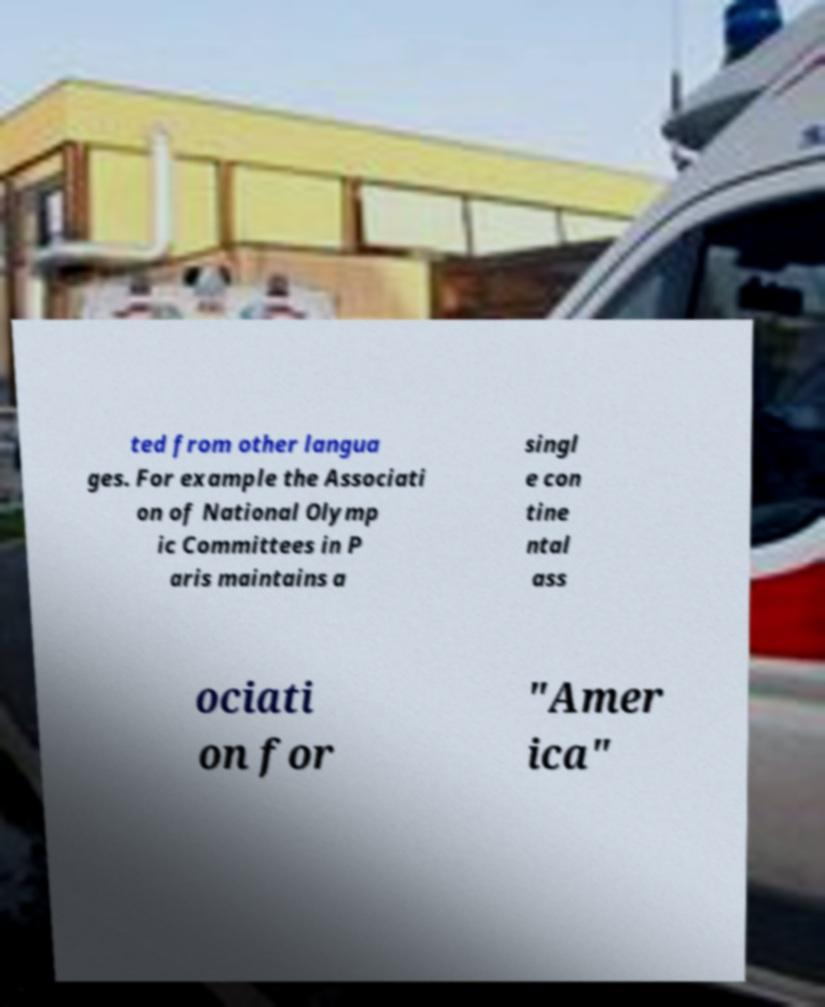There's text embedded in this image that I need extracted. Can you transcribe it verbatim? ted from other langua ges. For example the Associati on of National Olymp ic Committees in P aris maintains a singl e con tine ntal ass ociati on for "Amer ica" 